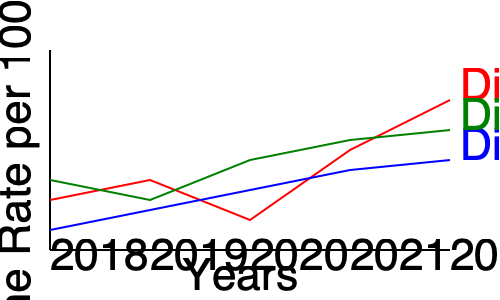Based on the line graph showing crime rate trends in three districts from 2018 to 2022, which district has shown the most consistent decrease in crime rate, and how might this information influence policy decisions? To answer this question, we need to analyze the trends for each district:

1. District A (red line):
   - Shows fluctuations, with an increase from 2019 to 2020, then a significant decrease from 2020 to 2022.
   - Overall trend is decreasing, but not consistent.

2. District B (blue line):
   - Shows a steady, consistent decrease from 2018 to 2022.
   - The slope of the line is relatively constant, indicating a uniform rate of decrease.

3. District C (green line):
   - Shows fluctuations, with an increase from 2018 to 2019, then a decrease from 2019 to 2022.
   - Overall trend is decreasing, but not consistent.

District B has shown the most consistent decrease in crime rate over the five-year period.

This information could influence policy decisions in several ways:
1. Allocating resources: More resources might be directed to Districts A and C to replicate the success of District B.
2. Identifying effective strategies: Policymakers might study the specific crime prevention and reduction strategies employed in District B.
3. Setting benchmarks: District B's performance could be used as a benchmark for other districts to aim for.
4. Targeted interventions: Specific policies could be developed to address the fluctuations in Districts A and C.
5. Long-term planning: The consistent decrease in District B suggests that sustained, long-term efforts can yield positive results in crime reduction.
Answer: District B; inform resource allocation, strategy replication, and targeted interventions. 